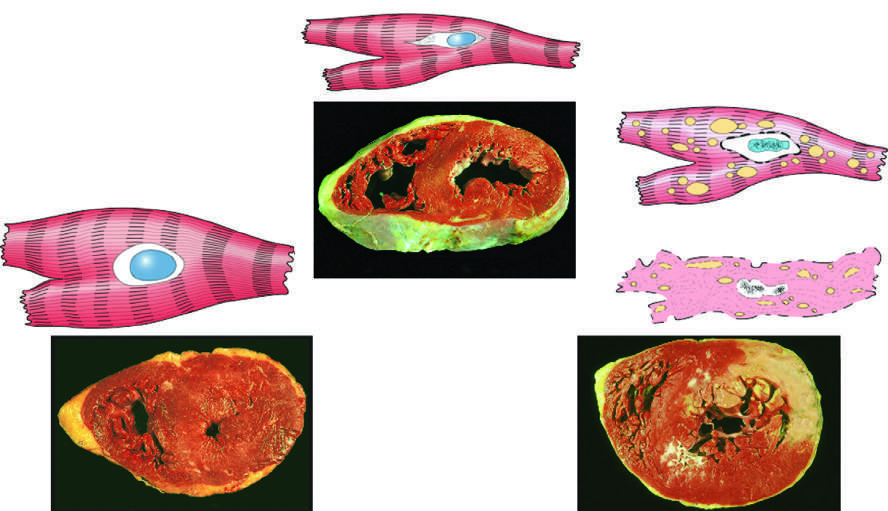what were stained with triphenyltetra-zolium chloride, an enzyme substrate that colors viable myocardium magenta?
Answer the question using a single word or phrase. All three transverse sections of myocardium 